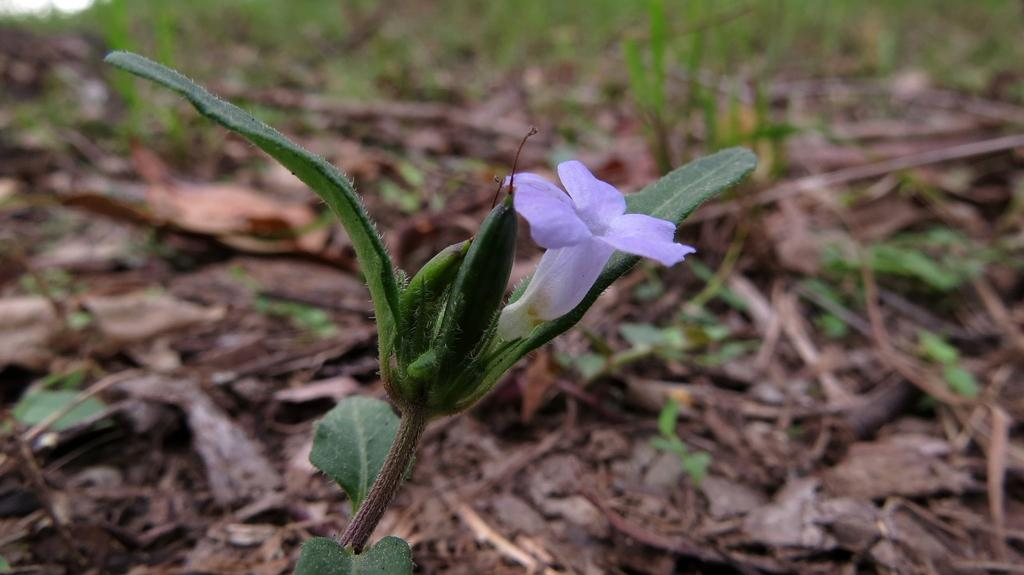What type of plant is featured in the image? There is a flower and a plant in the image. Can you describe the leaves visible in the background? The leaves are visible in the background of the image. How would you describe the overall appearance of the image? The background of the image appears blurry. What does the mouth of the flower look like in the image? There is no mention of a mouth or any specific flower type in the image, so it cannot be determined. 